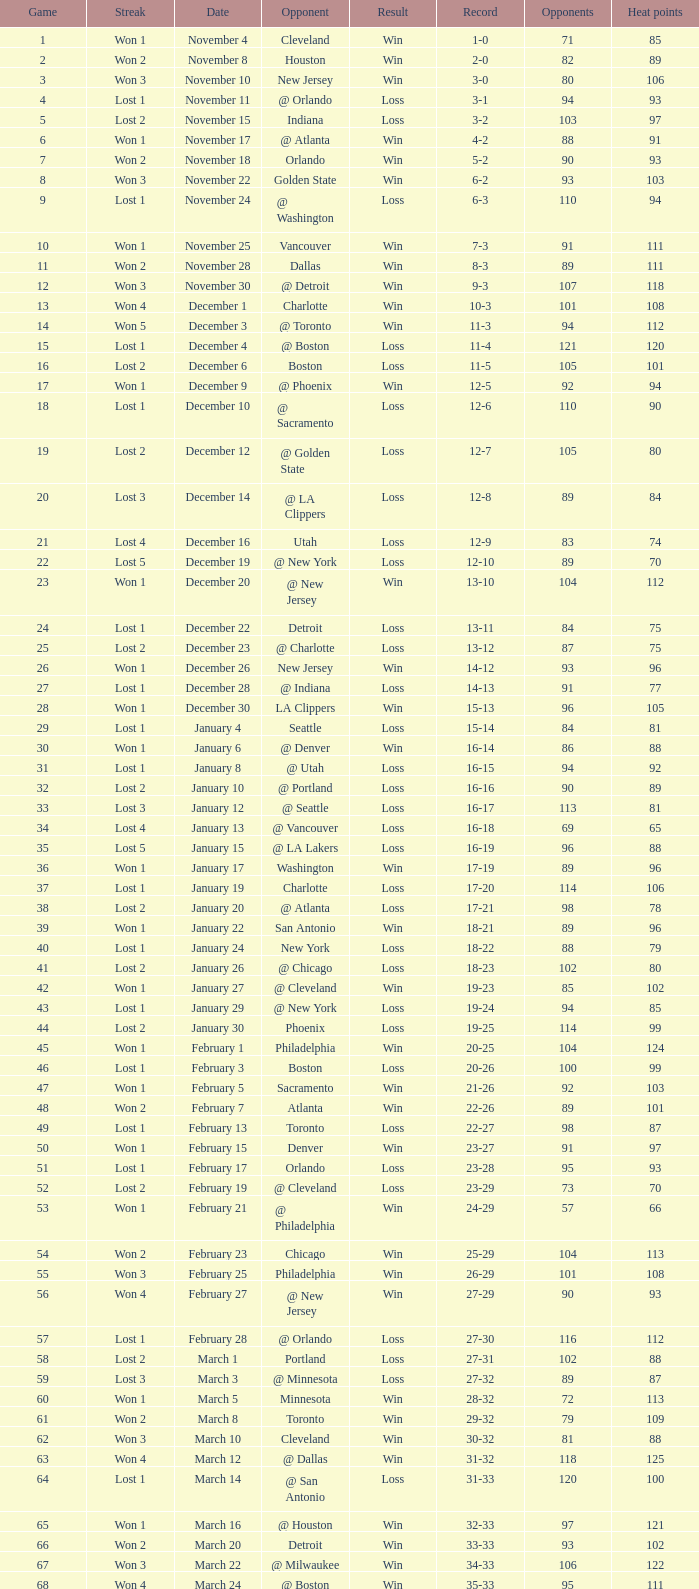What is Streak, when Heat Points is "101", and when Game is "16"? Lost 2. 